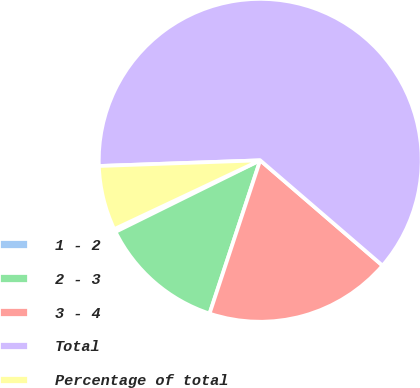<chart> <loc_0><loc_0><loc_500><loc_500><pie_chart><fcel>1 - 2<fcel>2 - 3<fcel>3 - 4<fcel>Total<fcel>Percentage of total<nl><fcel>0.3%<fcel>12.61%<fcel>18.77%<fcel>61.87%<fcel>6.45%<nl></chart> 